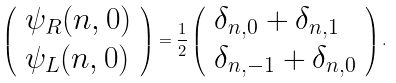Convert formula to latex. <formula><loc_0><loc_0><loc_500><loc_500>\left ( \begin{array} { l } \psi _ { R } ( n , 0 ) \\ \psi _ { L } ( n , 0 ) \end{array} \right ) = \frac { 1 } { 2 } \left ( \begin{array} { l } \delta _ { n , 0 } + \delta _ { n , 1 } \\ \delta _ { n , - 1 } + \delta _ { n , 0 } \end{array} \right ) .</formula> 